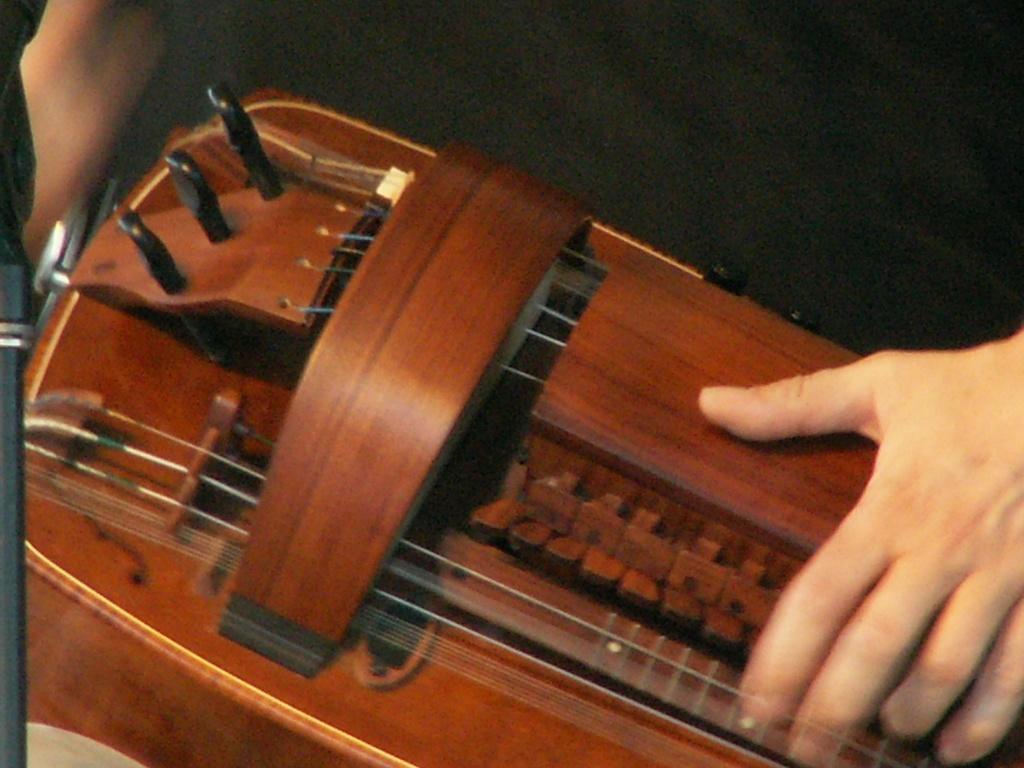Can you describe this image briefly? In this picture, we see the hands of the person who is playing the musical instrument. It is in brown color. At the top, it is black in color. 